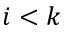Convert formula to latex. <formula><loc_0><loc_0><loc_500><loc_500>i < k</formula> 